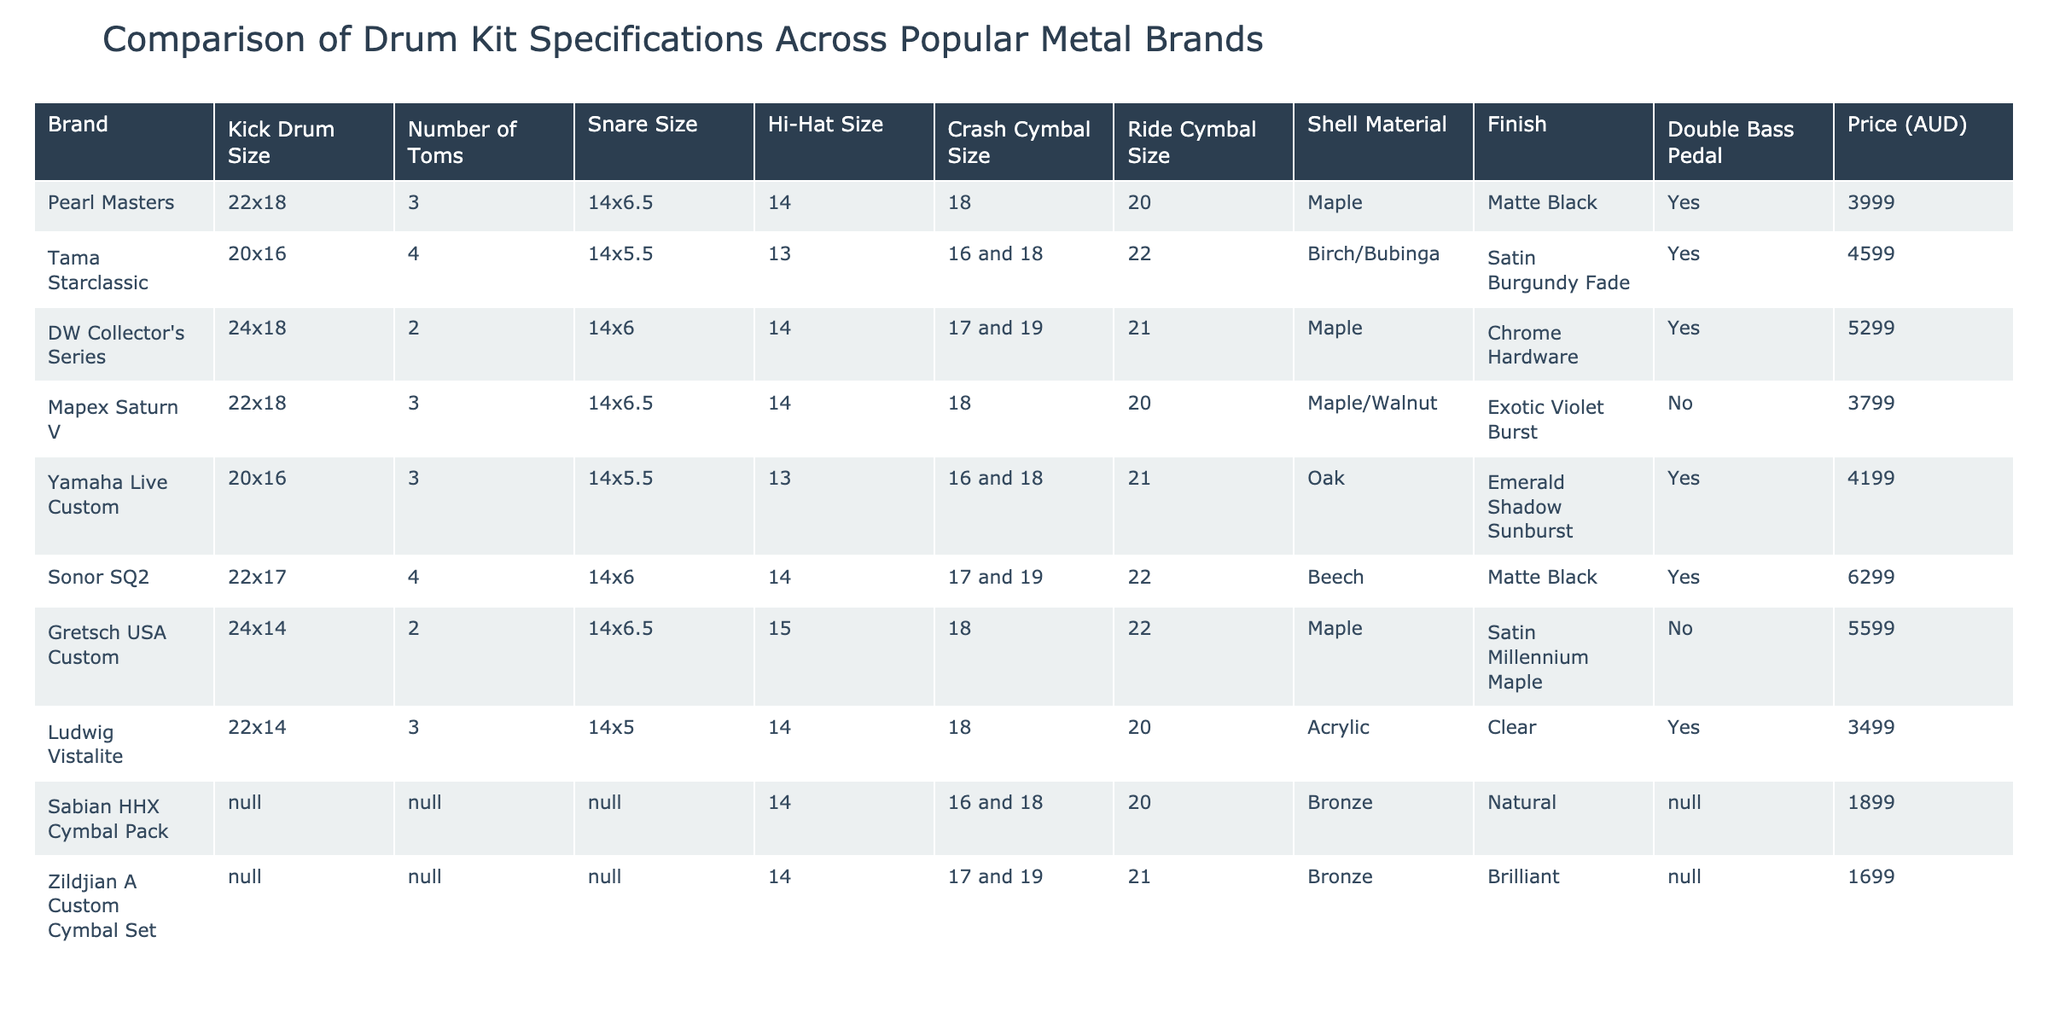What's the price of the DW Collector's Series drum kit? The DW Collector's Series has a price listed in the table, which is found under the "Price (AUD)" column. The value for DW Collector's Series is 5299.
Answer: 5299 How many brands offer a double bass pedal? To find the number of brands offering a double bass pedal, count the "Yes" responses in the "Double Bass Pedal" column. There are 6 brands with "Yes."
Answer: 6 What is the largest kick drum size among the listed brands? The kick drum sizes are compared in the "Kick Drum Size" column. The largest size is 24x18, which is associated with the DW Collector's Series and Gretsch USA Custom.
Answer: 24x18 Which brand has the smallest snare size and what is it? The snare sizes are listed in the "Snare Size" column. The smallest snare size mentioned is 14x5, which corresponds to the Ludwig Vistalite and Yamaha Live Custom.
Answer: 14x5 What is the average price of the drum kits? First, sum the prices of all drum kits: (3999 + 4599 + 5299 + 3799 + 4199 + 6299 + 5599 + 3499) = 39792. Then divide by the number of kits, which is 8: 39792 / 8 = 4974.
Answer: 4974 Which brand with a shell made of Birch/Bubinga has the most toms? From the table, check the "Number of Toms" for the Tama Starclassic, which is made of Birch/Bubinga and has 4 toms.
Answer: 4 True or False: All brands have a shell made of Maple. Check the "Shell Material" column for each brand. Not all brands have Maple; examples include Yamaha Live Custom (Oak) and Sonor SQ2 (Beech).
Answer: False What is the difference in price between the most expensive and least expensive drum kit? The most expensive drum kit is Sonor SQ2 at 6299, and the least expensive is Ludwig Vistalite at 3499. Calculate the difference: 6299 - 3499 = 2800.
Answer: 2800 Which brand offers the largest ride cymbal size? The "Ride Cymbal Size" column shows the sizes. The largest size is 22, which belongs to the Sonor SQ2.
Answer: 22 How many brands have both 3 toms and a double bass pedal? Review the "Number of Toms" and "Double Bass Pedal" columns. Pearl Masters, Yamaha Live Custom, and Mapex Saturn V all have 3 toms and offer a double bass pedal, totaling 3 brands.
Answer: 3 